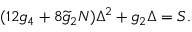Convert formula to latex. <formula><loc_0><loc_0><loc_500><loc_500>( 1 2 g _ { 4 } + 8 \widetilde { g } _ { 2 } N ) \Delta ^ { 2 } + g _ { 2 } \Delta = S .</formula> 